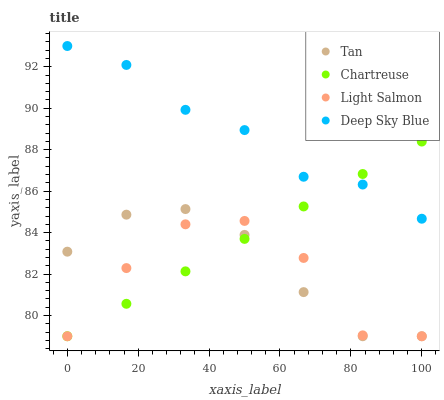Does Light Salmon have the minimum area under the curve?
Answer yes or no. Yes. Does Deep Sky Blue have the maximum area under the curve?
Answer yes or no. Yes. Does Chartreuse have the minimum area under the curve?
Answer yes or no. No. Does Chartreuse have the maximum area under the curve?
Answer yes or no. No. Is Chartreuse the smoothest?
Answer yes or no. Yes. Is Light Salmon the roughest?
Answer yes or no. Yes. Is Deep Sky Blue the smoothest?
Answer yes or no. No. Is Deep Sky Blue the roughest?
Answer yes or no. No. Does Tan have the lowest value?
Answer yes or no. Yes. Does Deep Sky Blue have the lowest value?
Answer yes or no. No. Does Deep Sky Blue have the highest value?
Answer yes or no. Yes. Does Chartreuse have the highest value?
Answer yes or no. No. Is Light Salmon less than Deep Sky Blue?
Answer yes or no. Yes. Is Deep Sky Blue greater than Tan?
Answer yes or no. Yes. Does Deep Sky Blue intersect Chartreuse?
Answer yes or no. Yes. Is Deep Sky Blue less than Chartreuse?
Answer yes or no. No. Is Deep Sky Blue greater than Chartreuse?
Answer yes or no. No. Does Light Salmon intersect Deep Sky Blue?
Answer yes or no. No. 